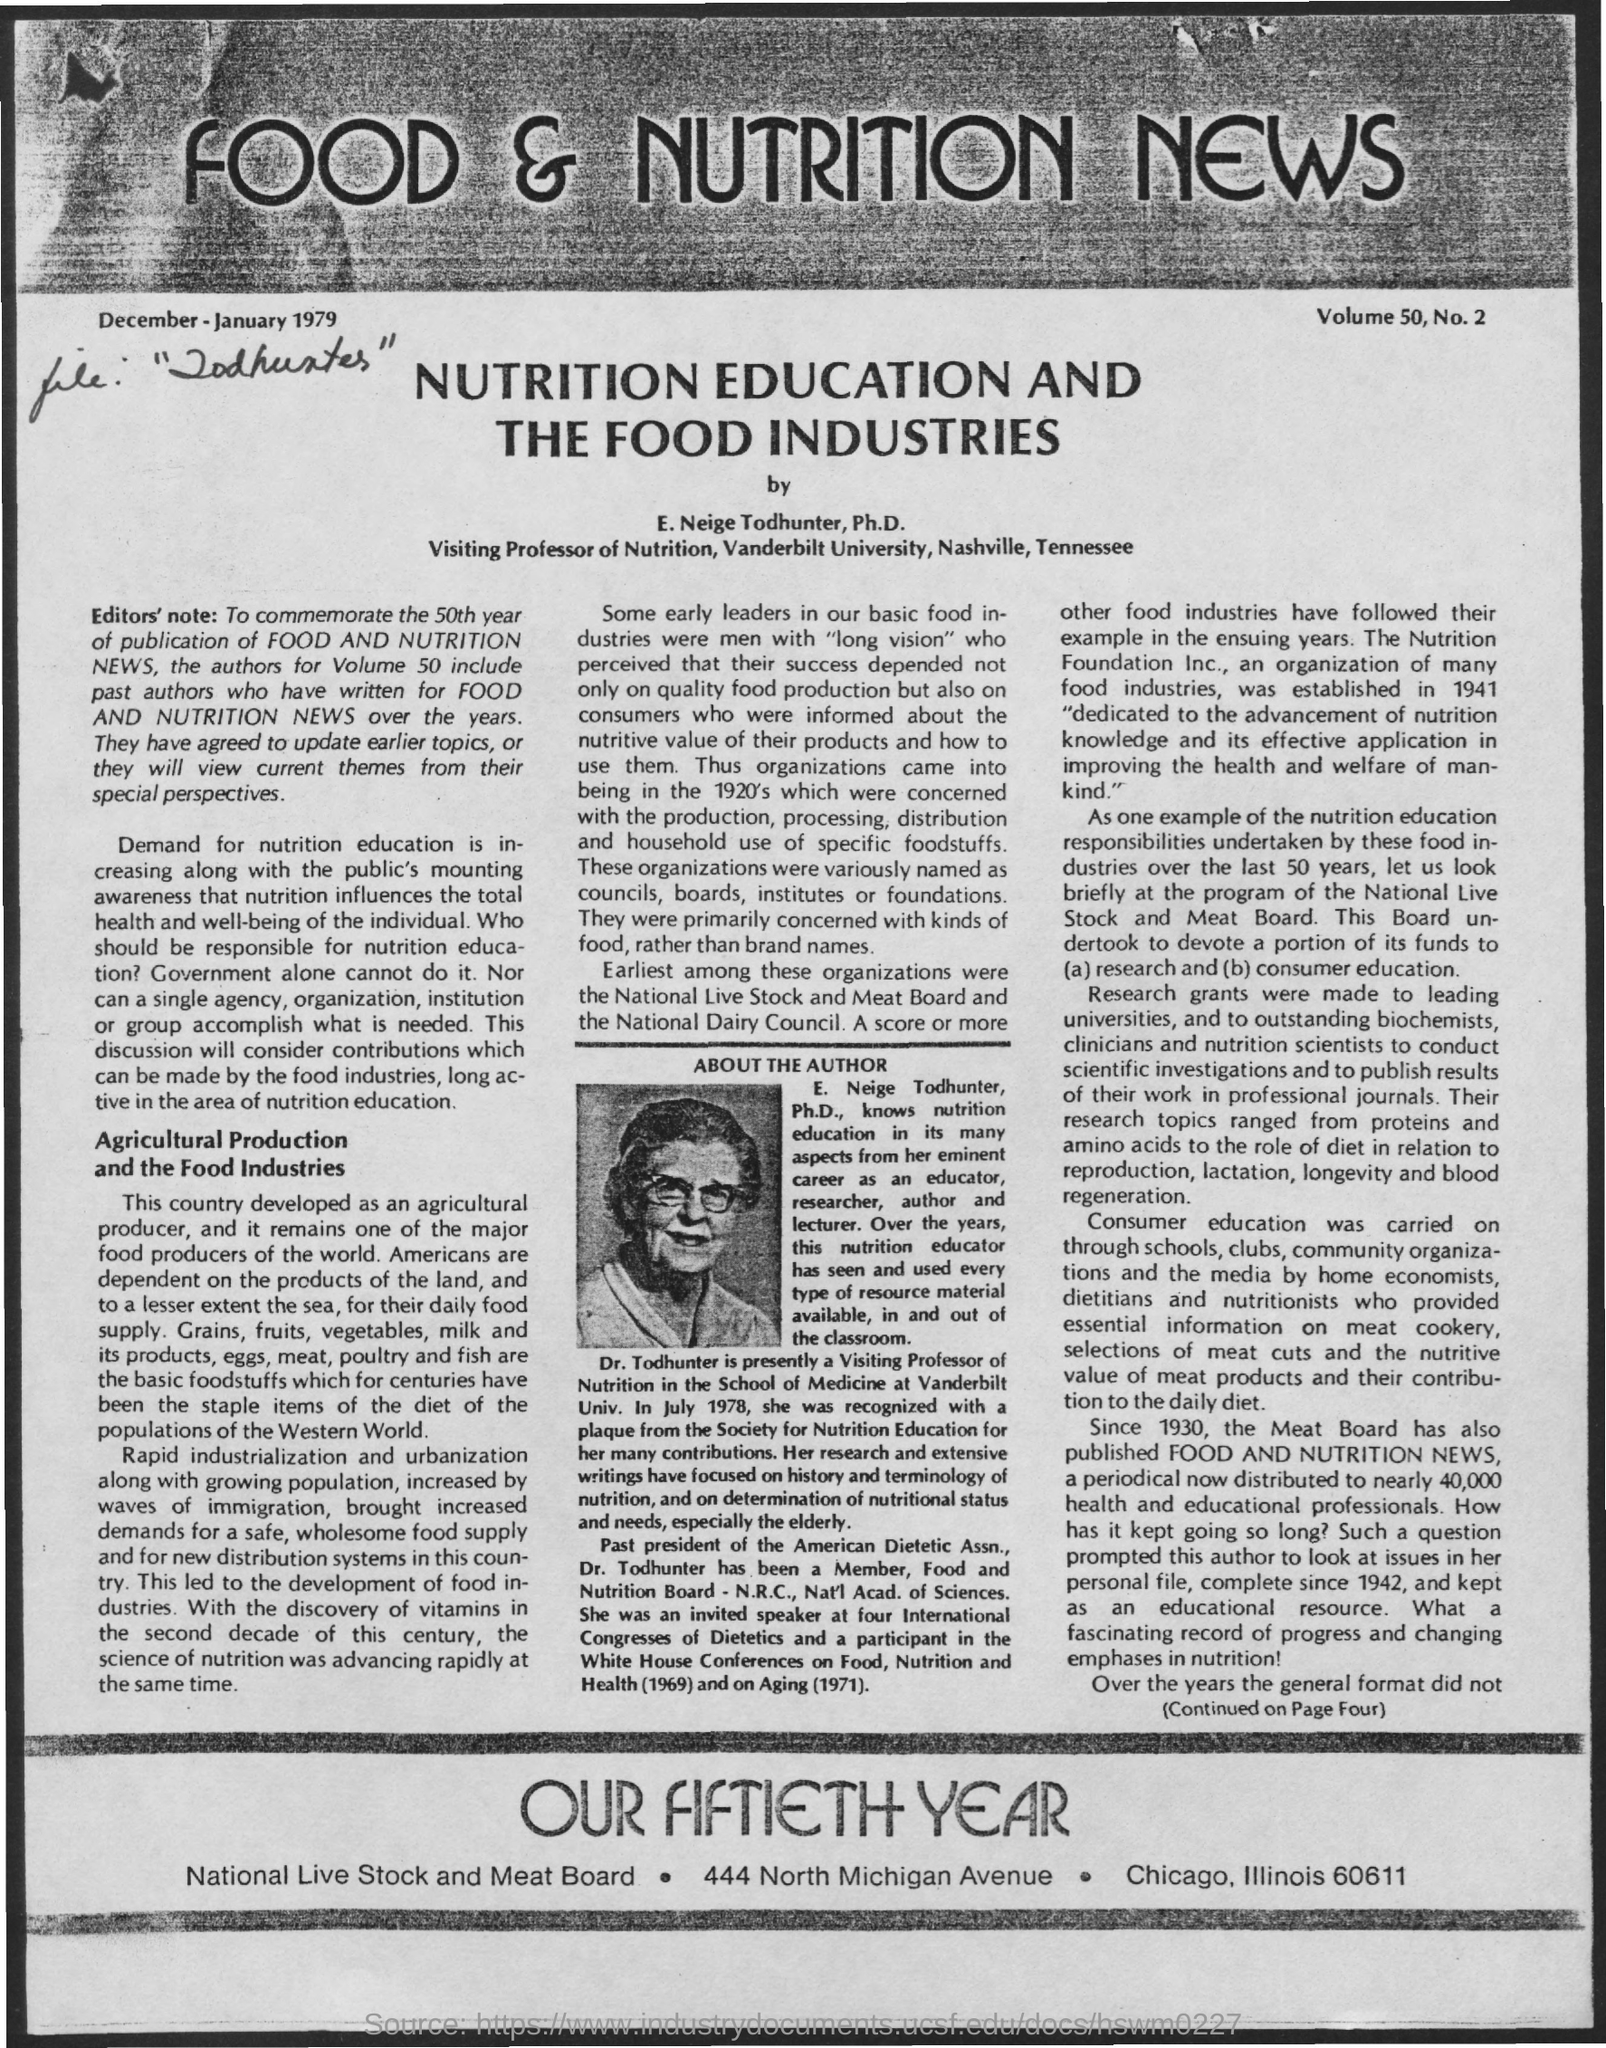Point out several critical features in this image. The university mentioned is Vanderbilt University. E. Neige Todhunter is a visiting professor of nutrition, as designated by her designation. The name of the author is E. Neige Todhunter. 